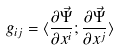Convert formula to latex. <formula><loc_0><loc_0><loc_500><loc_500>g _ { i j } = \langle \frac { \partial \vec { \Psi } } { \partial x ^ { i } } ; \frac { \partial \vec { \Psi } } { \partial x ^ { j } } \rangle</formula> 